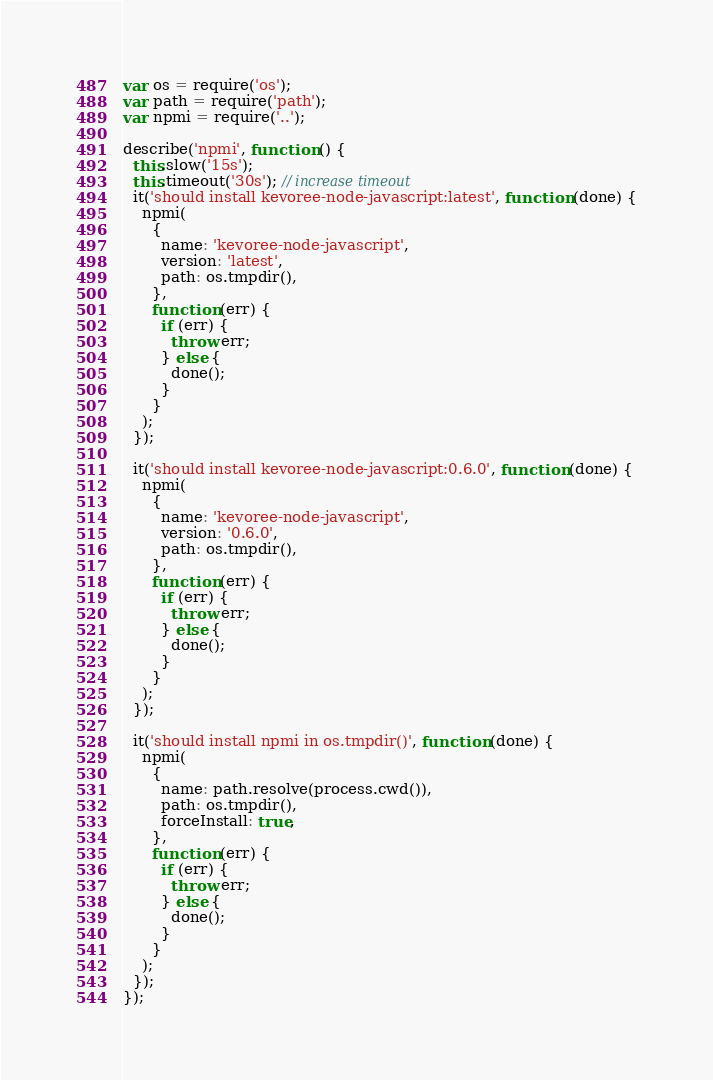<code> <loc_0><loc_0><loc_500><loc_500><_JavaScript_>var os = require('os');
var path = require('path');
var npmi = require('..');

describe('npmi', function () {
  this.slow('15s');
  this.timeout('30s'); // increase timeout
  it('should install kevoree-node-javascript:latest', function (done) {
    npmi(
      {
        name: 'kevoree-node-javascript',
        version: 'latest',
        path: os.tmpdir(),
      },
      function (err) {
        if (err) {
          throw err;
        } else {
          done();
        }
      }
    );
  });

  it('should install kevoree-node-javascript:0.6.0', function (done) {
    npmi(
      {
        name: 'kevoree-node-javascript',
        version: '0.6.0',
        path: os.tmpdir(),
      },
      function (err) {
        if (err) {
          throw err;
        } else {
          done();
        }
      }
    );
  });

  it('should install npmi in os.tmpdir()', function (done) {
    npmi(
      {
        name: path.resolve(process.cwd()),
        path: os.tmpdir(),
        forceInstall: true,
      },
      function (err) {
        if (err) {
          throw err;
        } else {
          done();
        }
      }
    );
  });
});
</code> 